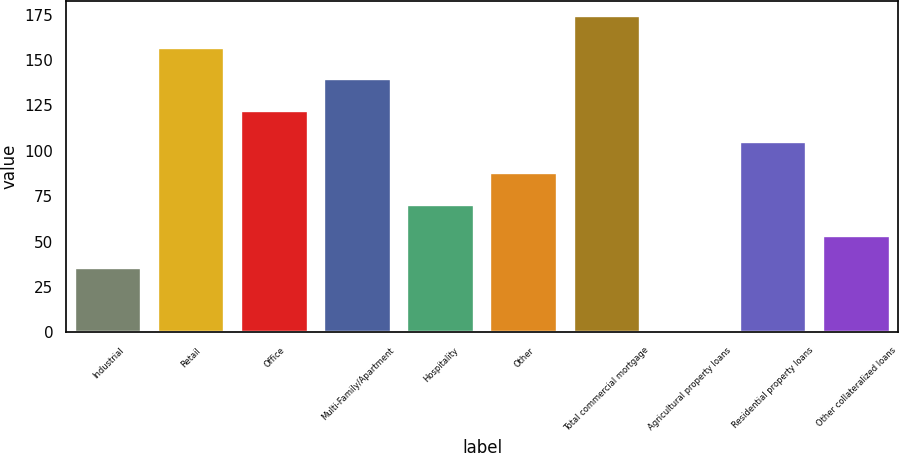Convert chart to OTSL. <chart><loc_0><loc_0><loc_500><loc_500><bar_chart><fcel>Industrial<fcel>Retail<fcel>Office<fcel>Multi-Family/Apartment<fcel>Hospitality<fcel>Other<fcel>Total commercial mortgage<fcel>Agricultural property loans<fcel>Residential property loans<fcel>Other collateralized loans<nl><fcel>35.6<fcel>156.7<fcel>122.1<fcel>139.4<fcel>70.2<fcel>87.5<fcel>174<fcel>1<fcel>104.8<fcel>52.9<nl></chart> 